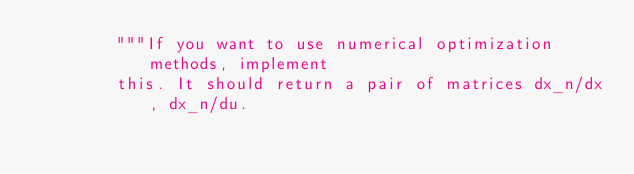Convert code to text. <code><loc_0><loc_0><loc_500><loc_500><_Python_>        """If you want to use numerical optimization methods, implement
        this. It should return a pair of matrices dx_n/dx, dx_n/du.</code> 